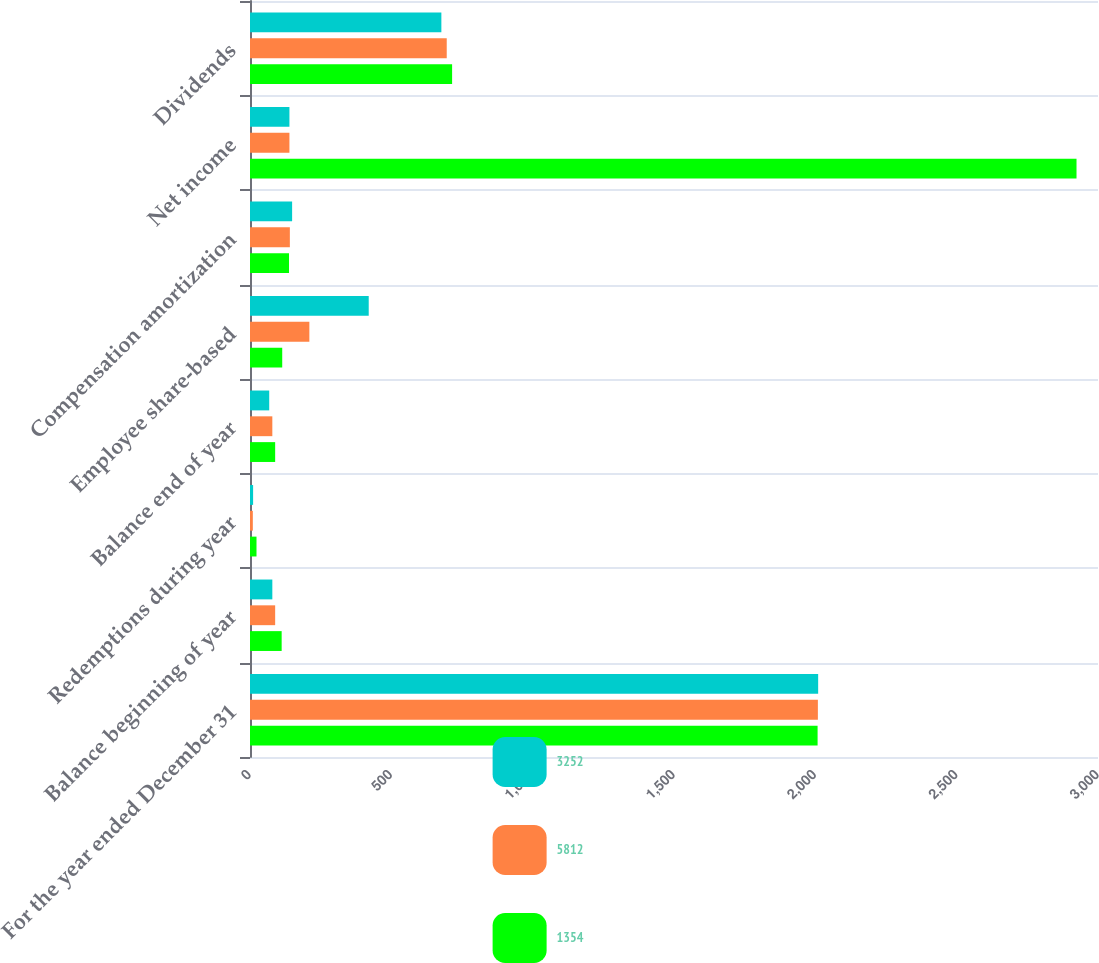Convert chart. <chart><loc_0><loc_0><loc_500><loc_500><stacked_bar_chart><ecel><fcel>For the year ended December 31<fcel>Balance beginning of year<fcel>Redemptions during year<fcel>Balance end of year<fcel>Employee share-based<fcel>Compensation amortization<fcel>Net income<fcel>Dividends<nl><fcel>3252<fcel>2010<fcel>79<fcel>11<fcel>68<fcel>420<fcel>149<fcel>139.5<fcel>677<nl><fcel>5812<fcel>2009<fcel>89<fcel>10<fcel>79<fcel>210<fcel>141<fcel>139.5<fcel>696<nl><fcel>1354<fcel>2008<fcel>112<fcel>23<fcel>89<fcel>114<fcel>138<fcel>2924<fcel>715<nl></chart> 